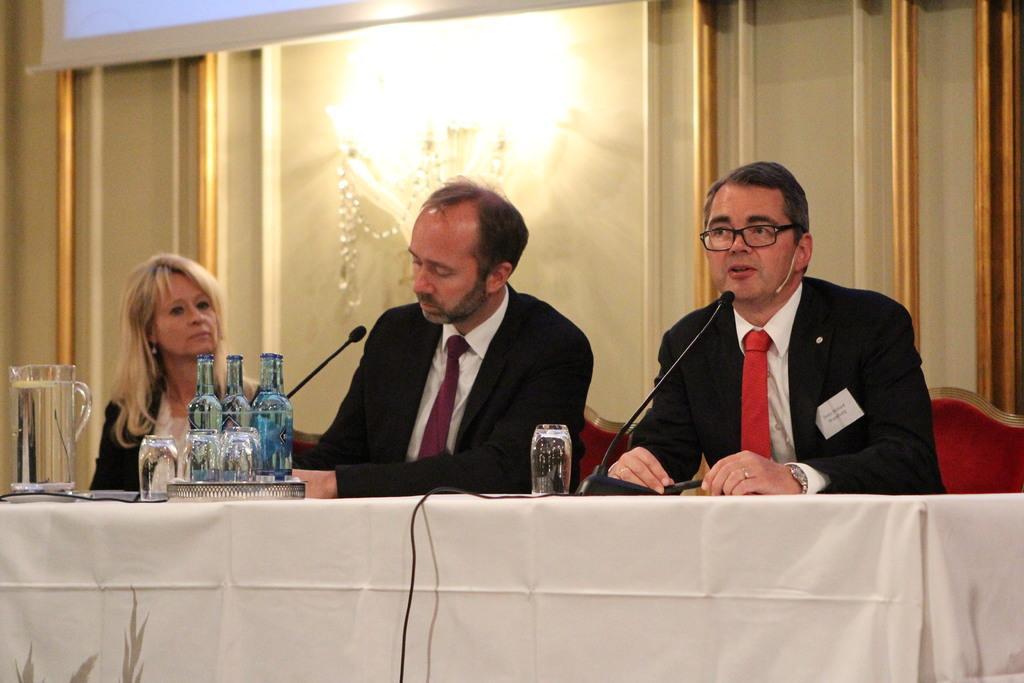In one or two sentences, can you explain what this image depicts? In this image, there are a few people sitting. We can see a table covered with a cloth and some objects like glasses, bottles, microphones and wires. We can also see the wall with some objects. We can see a screen at the top. We can see some light. 